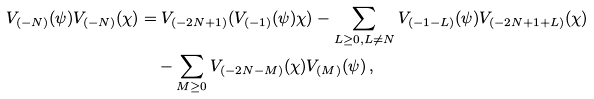Convert formula to latex. <formula><loc_0><loc_0><loc_500><loc_500>V _ { ( - N ) } ( \psi ) V _ { ( - N ) } ( \chi ) & = V _ { ( - 2 N + 1 ) } ( V _ { ( - 1 ) } ( \psi ) \chi ) - \sum _ { L \geq 0 , L \ne N } V _ { ( - 1 - L ) } ( \psi ) V _ { ( - 2 N + 1 + L ) } ( \chi ) \\ & \quad - \sum _ { M \geq 0 } V _ { ( - 2 N - M ) } ( \chi ) V _ { ( M ) } ( \psi ) \, ,</formula> 